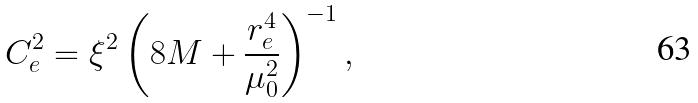Convert formula to latex. <formula><loc_0><loc_0><loc_500><loc_500>C _ { e } ^ { 2 } = { \xi } ^ { 2 } \left ( 8 M + \frac { r _ { e } ^ { 4 } } { { \mu _ { 0 } ^ { 2 } } } \right ) ^ { - 1 } ,</formula> 